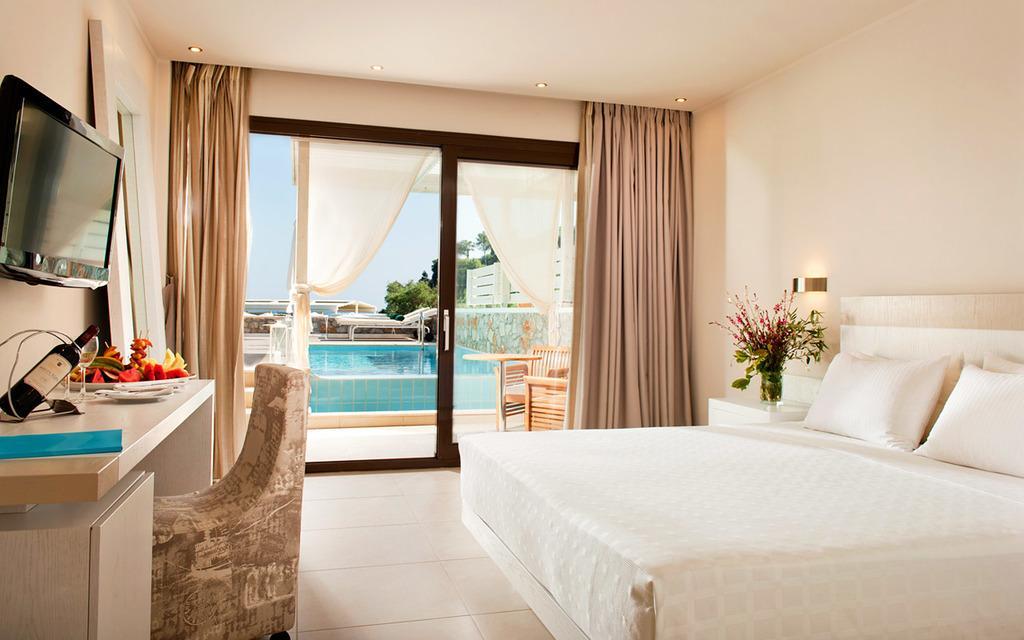Can you describe this image briefly? In the center of the image there is a wall, table, bed, glass, monitor, bottle, chair, vase with flowers and leaves, curtains, pillows, lights and a few other objects. Through the glass, we can see the sky, trees, water and a few other objects. 